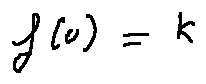<formula> <loc_0><loc_0><loc_500><loc_500>f ( u ) = k</formula> 